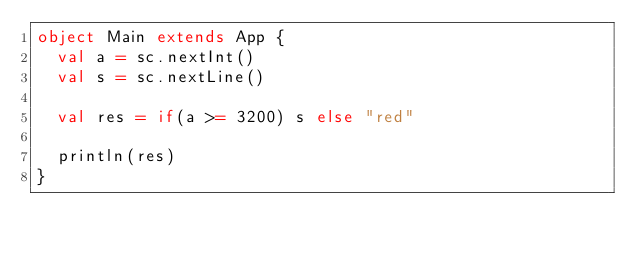<code> <loc_0><loc_0><loc_500><loc_500><_Scala_>object Main extends App {
  val a = sc.nextInt()
  val s = sc.nextLine()

  val res = if(a >= 3200) s else "red"

  println(res)
}
</code> 